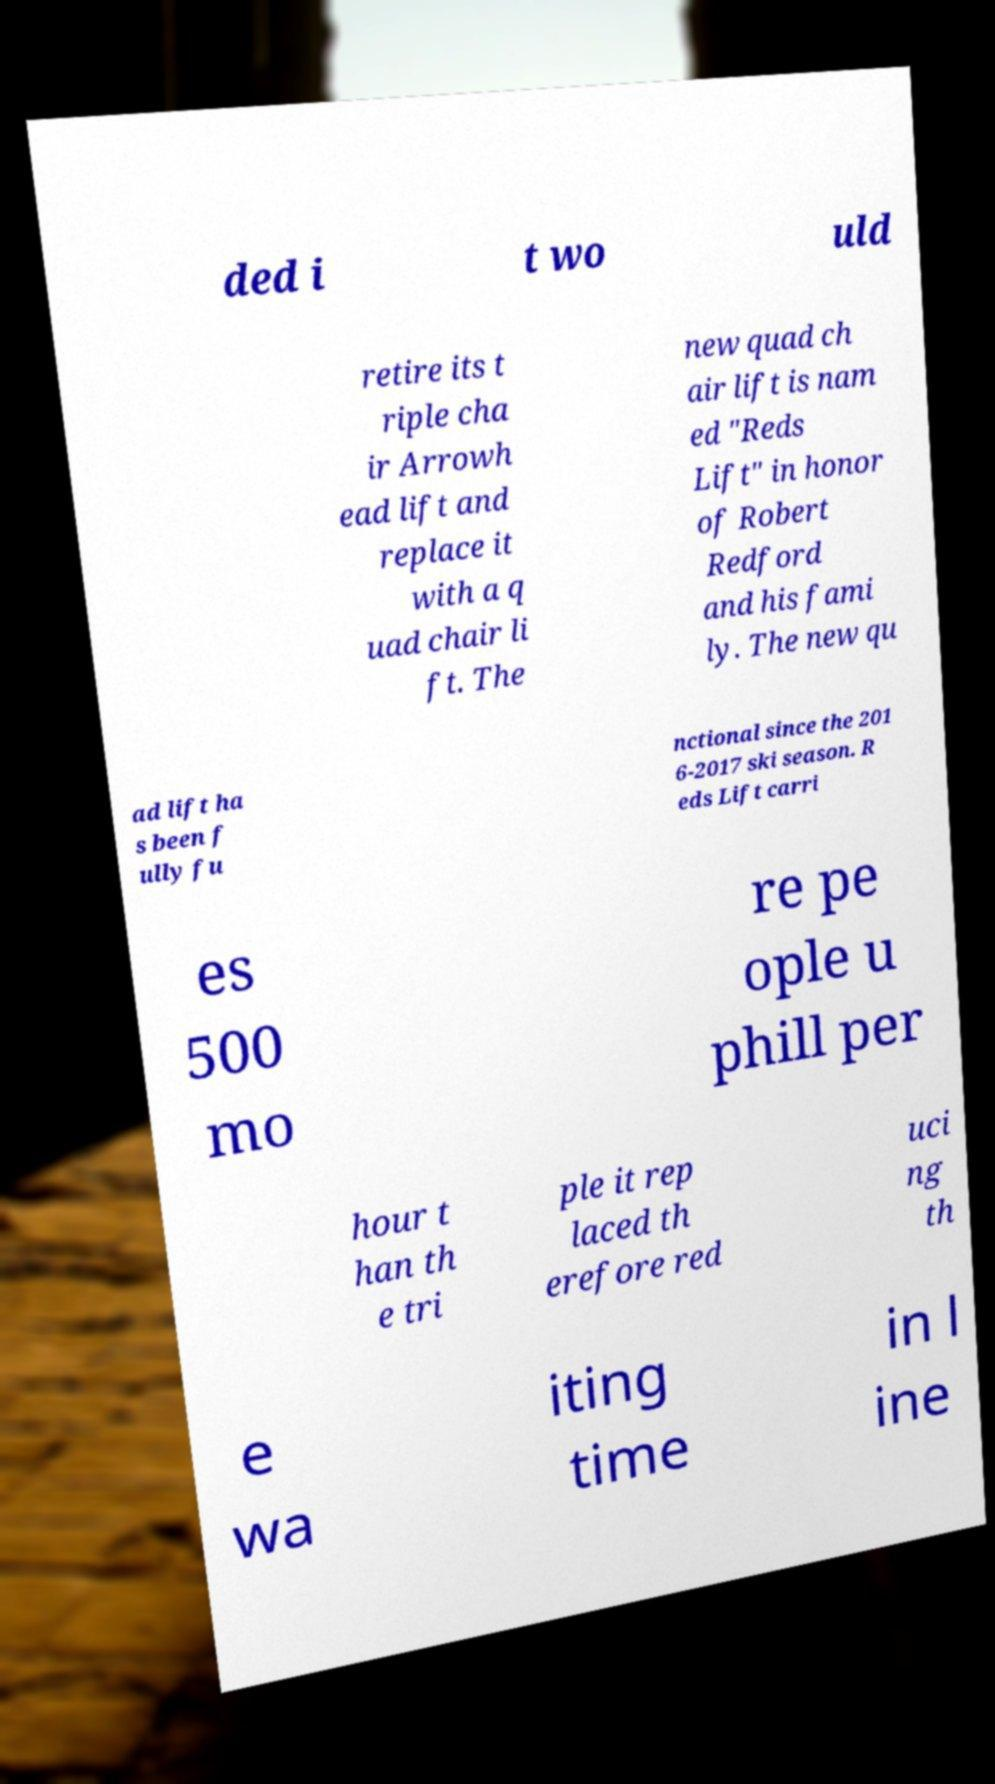I need the written content from this picture converted into text. Can you do that? ded i t wo uld retire its t riple cha ir Arrowh ead lift and replace it with a q uad chair li ft. The new quad ch air lift is nam ed "Reds Lift" in honor of Robert Redford and his fami ly. The new qu ad lift ha s been f ully fu nctional since the 201 6-2017 ski season. R eds Lift carri es 500 mo re pe ople u phill per hour t han th e tri ple it rep laced th erefore red uci ng th e wa iting time in l ine 